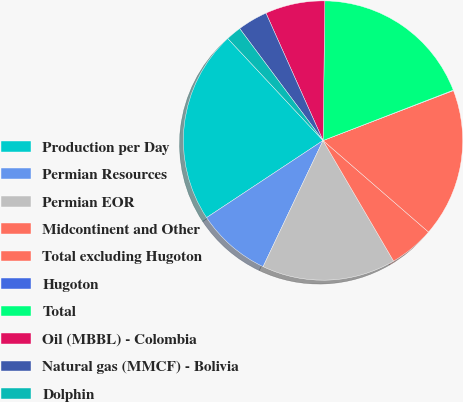Convert chart to OTSL. <chart><loc_0><loc_0><loc_500><loc_500><pie_chart><fcel>Production per Day<fcel>Permian Resources<fcel>Permian EOR<fcel>Midcontinent and Other<fcel>Total excluding Hugoton<fcel>Hugoton<fcel>Total<fcel>Oil (MBBL) - Colombia<fcel>Natural gas (MMCF) - Bolivia<fcel>Dolphin<nl><fcel>22.35%<fcel>8.63%<fcel>15.49%<fcel>5.2%<fcel>17.2%<fcel>0.05%<fcel>18.92%<fcel>6.91%<fcel>3.48%<fcel>1.77%<nl></chart> 